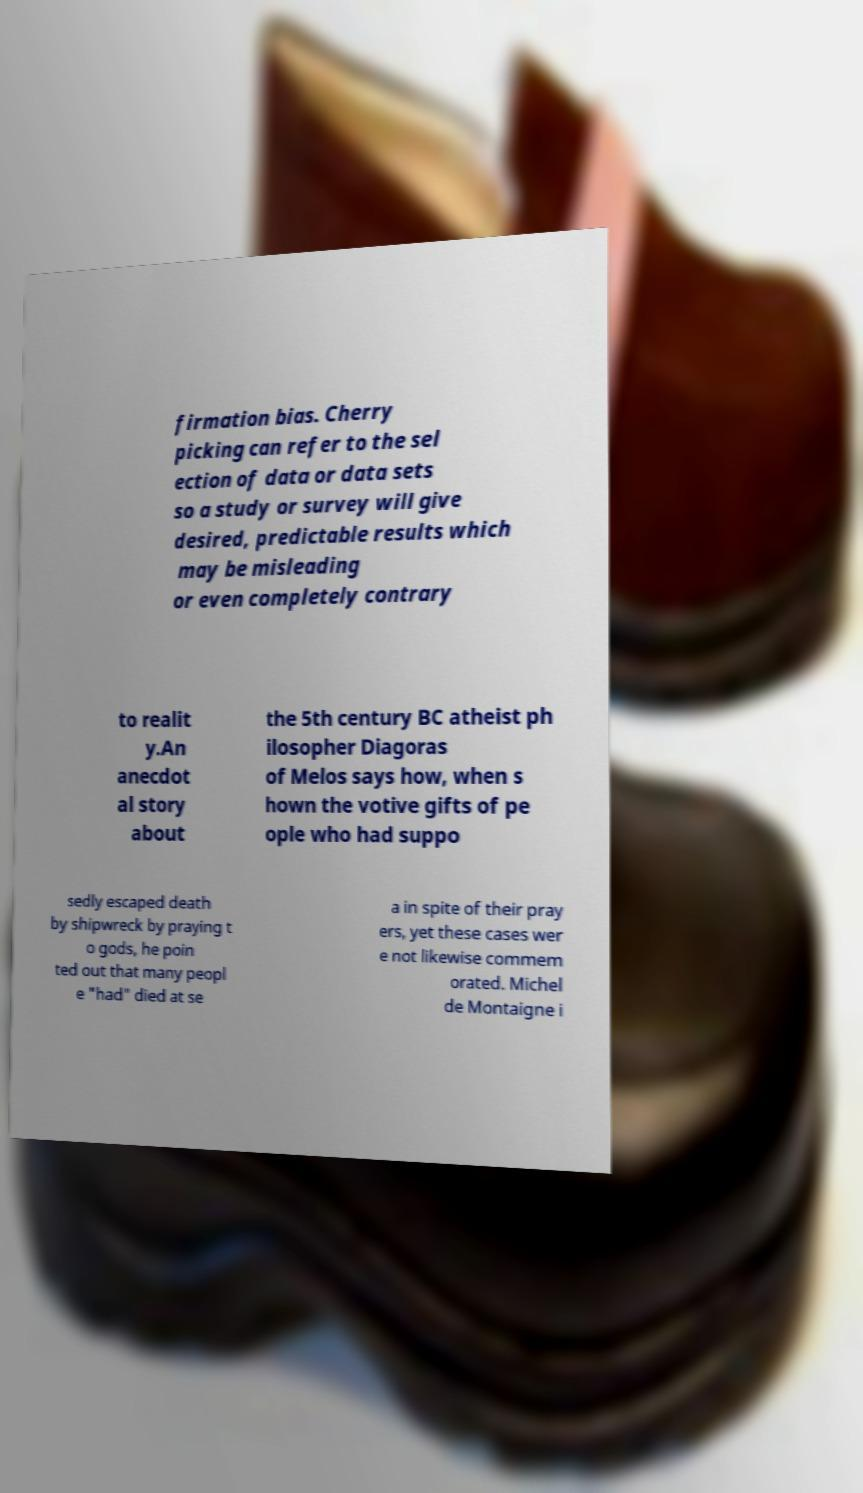Could you extract and type out the text from this image? firmation bias. Cherry picking can refer to the sel ection of data or data sets so a study or survey will give desired, predictable results which may be misleading or even completely contrary to realit y.An anecdot al story about the 5th century BC atheist ph ilosopher Diagoras of Melos says how, when s hown the votive gifts of pe ople who had suppo sedly escaped death by shipwreck by praying t o gods, he poin ted out that many peopl e "had" died at se a in spite of their pray ers, yet these cases wer e not likewise commem orated. Michel de Montaigne i 